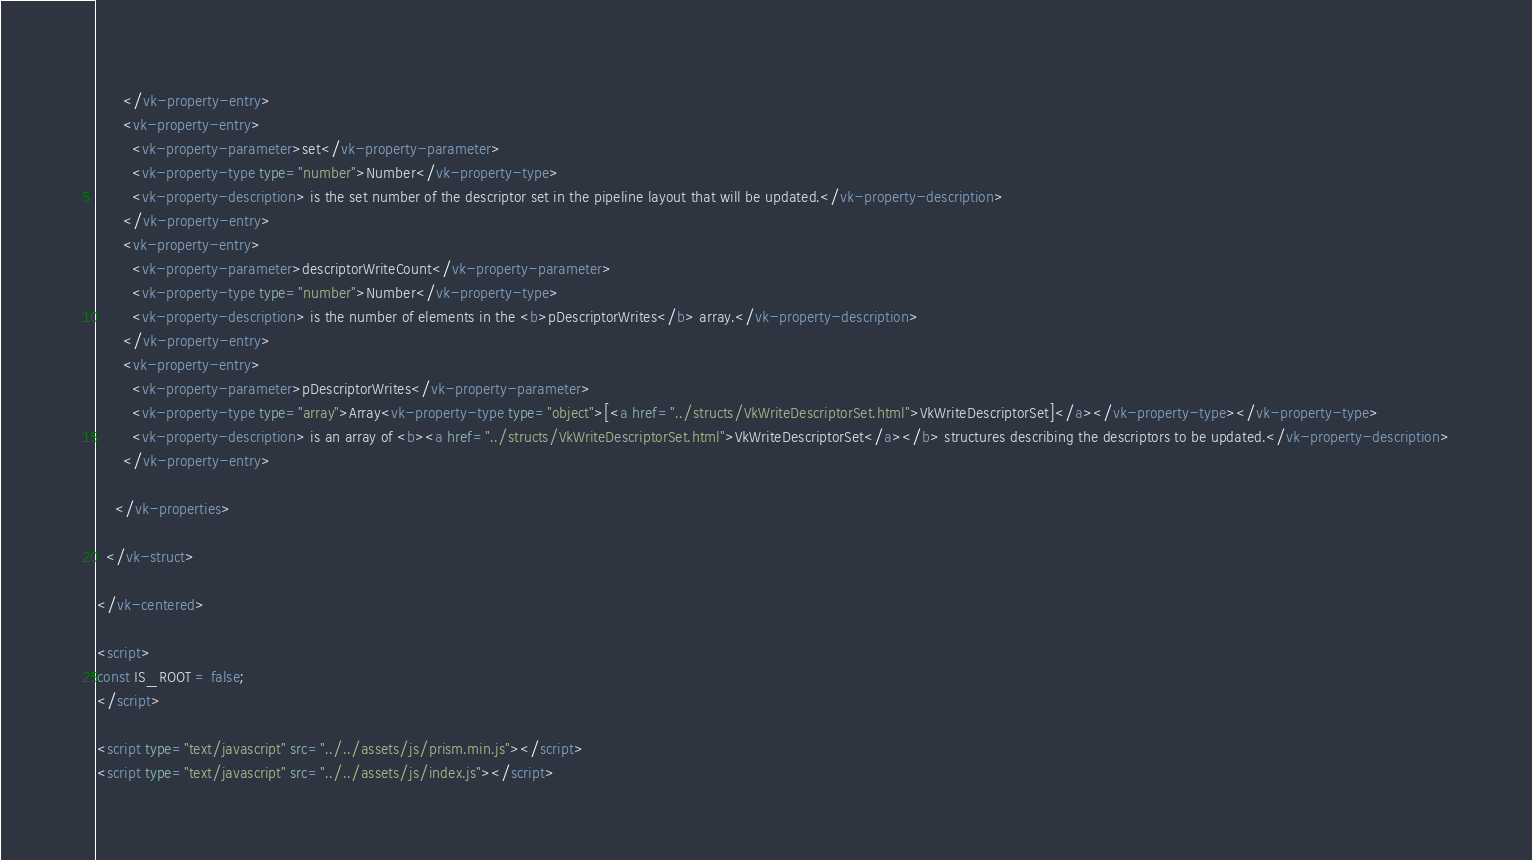Convert code to text. <code><loc_0><loc_0><loc_500><loc_500><_HTML_>      </vk-property-entry>
      <vk-property-entry>
        <vk-property-parameter>set</vk-property-parameter>
        <vk-property-type type="number">Number</vk-property-type>
        <vk-property-description> is the set number of the descriptor set in the pipeline layout that will be updated.</vk-property-description>
      </vk-property-entry>
      <vk-property-entry>
        <vk-property-parameter>descriptorWriteCount</vk-property-parameter>
        <vk-property-type type="number">Number</vk-property-type>
        <vk-property-description> is the number of elements in the <b>pDescriptorWrites</b> array.</vk-property-description>
      </vk-property-entry>
      <vk-property-entry>
        <vk-property-parameter>pDescriptorWrites</vk-property-parameter>
        <vk-property-type type="array">Array<vk-property-type type="object">[<a href="../structs/VkWriteDescriptorSet.html">VkWriteDescriptorSet]</a></vk-property-type></vk-property-type>
        <vk-property-description> is an array of <b><a href="../structs/VkWriteDescriptorSet.html">VkWriteDescriptorSet</a></b> structures describing the descriptors to be updated.</vk-property-description>
      </vk-property-entry>
      
    </vk-properties>

  </vk-struct>

</vk-centered>

<script>
const IS_ROOT = false;
</script>

<script type="text/javascript" src="../../assets/js/prism.min.js"></script>
<script type="text/javascript" src="../../assets/js/index.js"></script>
</code> 